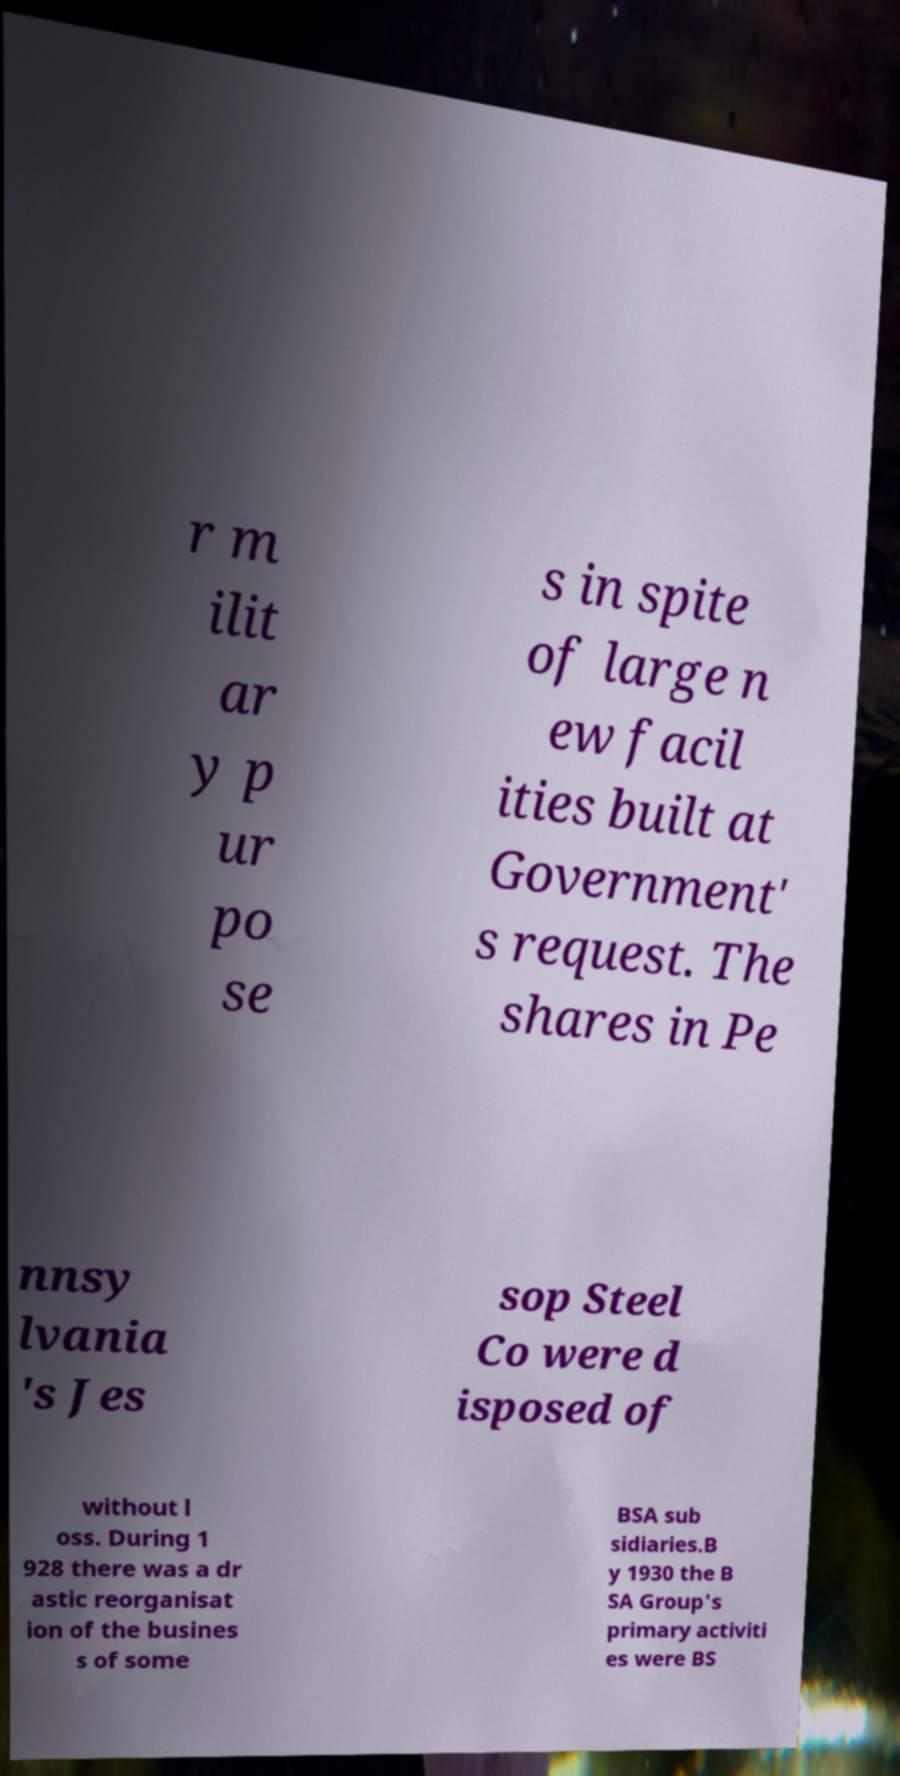For documentation purposes, I need the text within this image transcribed. Could you provide that? r m ilit ar y p ur po se s in spite of large n ew facil ities built at Government' s request. The shares in Pe nnsy lvania 's Jes sop Steel Co were d isposed of without l oss. During 1 928 there was a dr astic reorganisat ion of the busines s of some BSA sub sidiaries.B y 1930 the B SA Group's primary activiti es were BS 